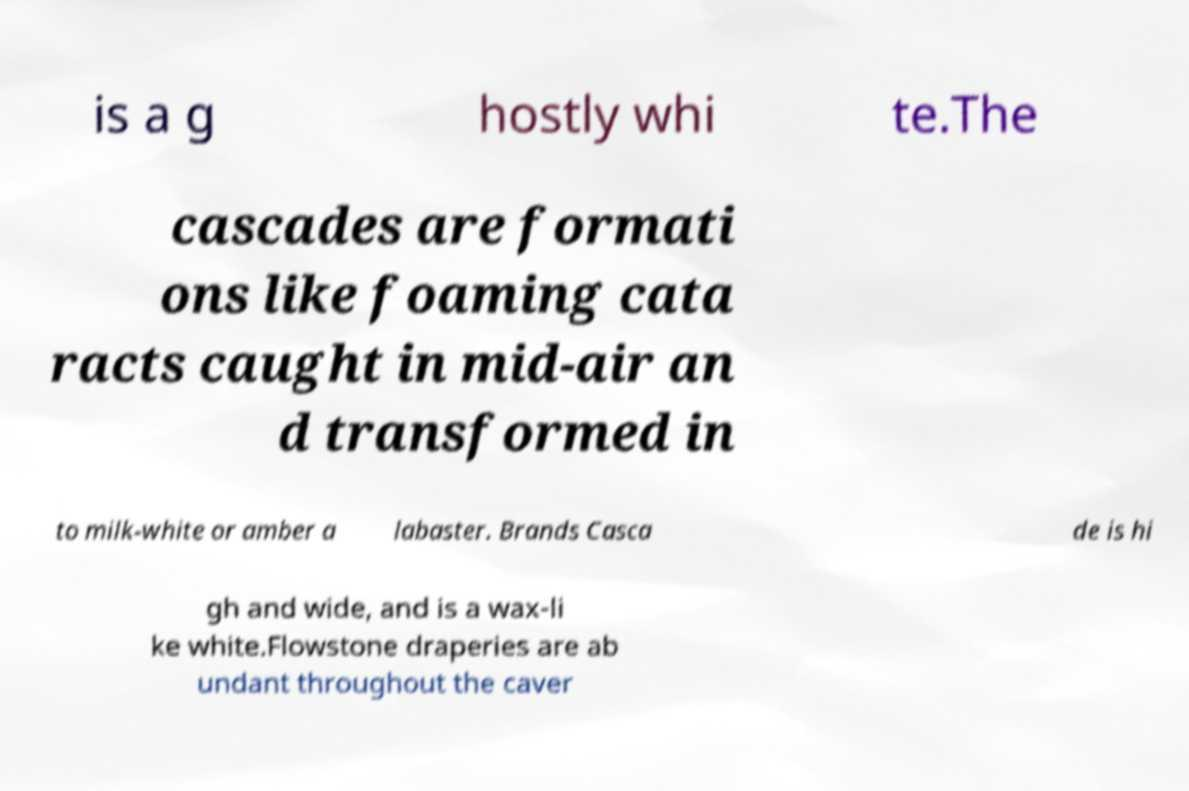Please read and relay the text visible in this image. What does it say? is a g hostly whi te.The cascades are formati ons like foaming cata racts caught in mid-air an d transformed in to milk-white or amber a labaster. Brands Casca de is hi gh and wide, and is a wax-li ke white.Flowstone draperies are ab undant throughout the caver 